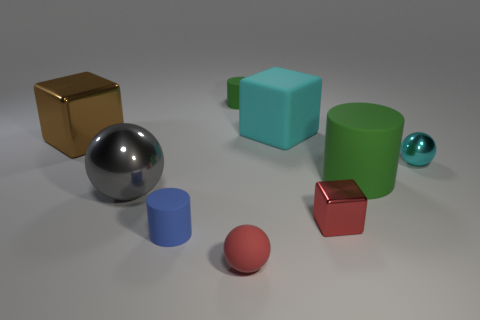Are there any tiny cyan objects that have the same material as the big gray sphere?
Give a very brief answer. Yes. How many metal things are either gray spheres or gray cylinders?
Offer a terse response. 1. What is the shape of the cyan object that is to the right of the shiny cube that is in front of the gray metal object?
Your answer should be compact. Sphere. Is the number of large things that are to the right of the red metallic block less than the number of red things?
Offer a very short reply. Yes. What shape is the gray metallic object?
Keep it short and to the point. Sphere. There is a thing that is to the left of the large ball; what is its size?
Provide a succinct answer. Large. There is a rubber ball that is the same size as the red cube; what color is it?
Keep it short and to the point. Red. Is there a large metal ball that has the same color as the tiny metal ball?
Offer a very short reply. No. Are there fewer matte balls behind the big green rubber object than metal objects that are in front of the gray object?
Offer a very short reply. Yes. What is the block that is both in front of the big rubber block and to the right of the large brown shiny block made of?
Provide a succinct answer. Metal. 